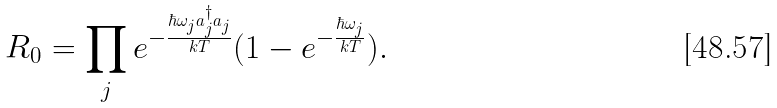Convert formula to latex. <formula><loc_0><loc_0><loc_500><loc_500>R _ { 0 } = \prod _ { j } e ^ { - \frac { \hbar { \omega } _ { j } a _ { j } ^ { \dagger } a _ { j } } { k T } } ( 1 - e ^ { - \frac { \hbar { \omega } _ { j } } { k T } } ) .</formula> 